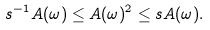<formula> <loc_0><loc_0><loc_500><loc_500>s ^ { - 1 } A ( \omega ) \leq A ( \omega ) ^ { 2 } \leq s A ( \omega ) .</formula> 